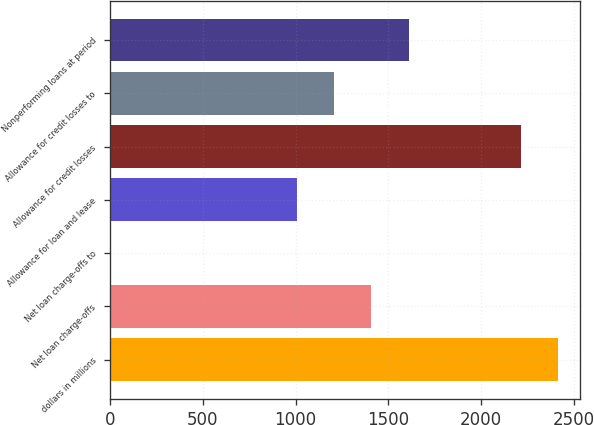<chart> <loc_0><loc_0><loc_500><loc_500><bar_chart><fcel>dollars in millions<fcel>Net loan charge-offs<fcel>Net loan charge-offs to<fcel>Allowance for loan and lease<fcel>Allowance for credit losses<fcel>Allowance for credit losses to<fcel>Nonperforming loans at period<nl><fcel>2412.99<fcel>1408.04<fcel>1.11<fcel>1006.06<fcel>2212<fcel>1207.05<fcel>1609.03<nl></chart> 